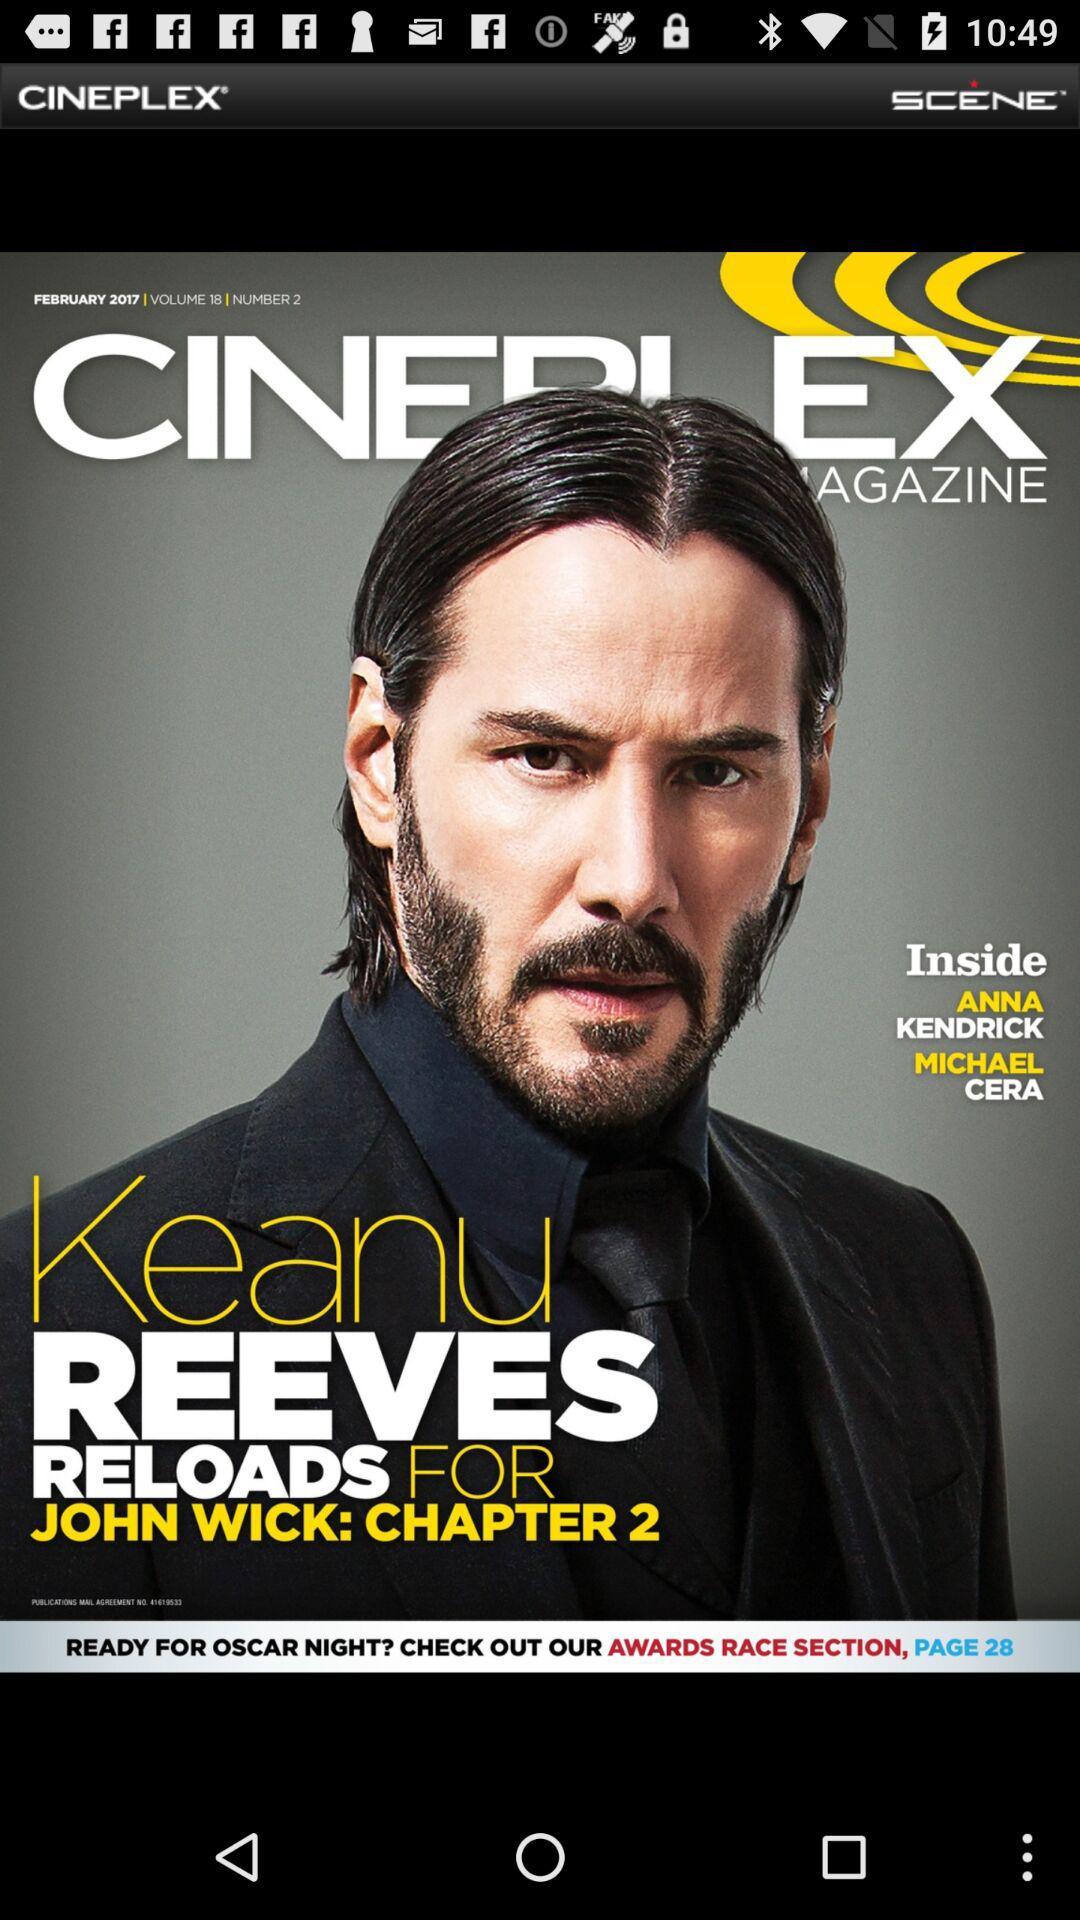What is the name of the actor? The name of the actor is Keanu Reeves. 